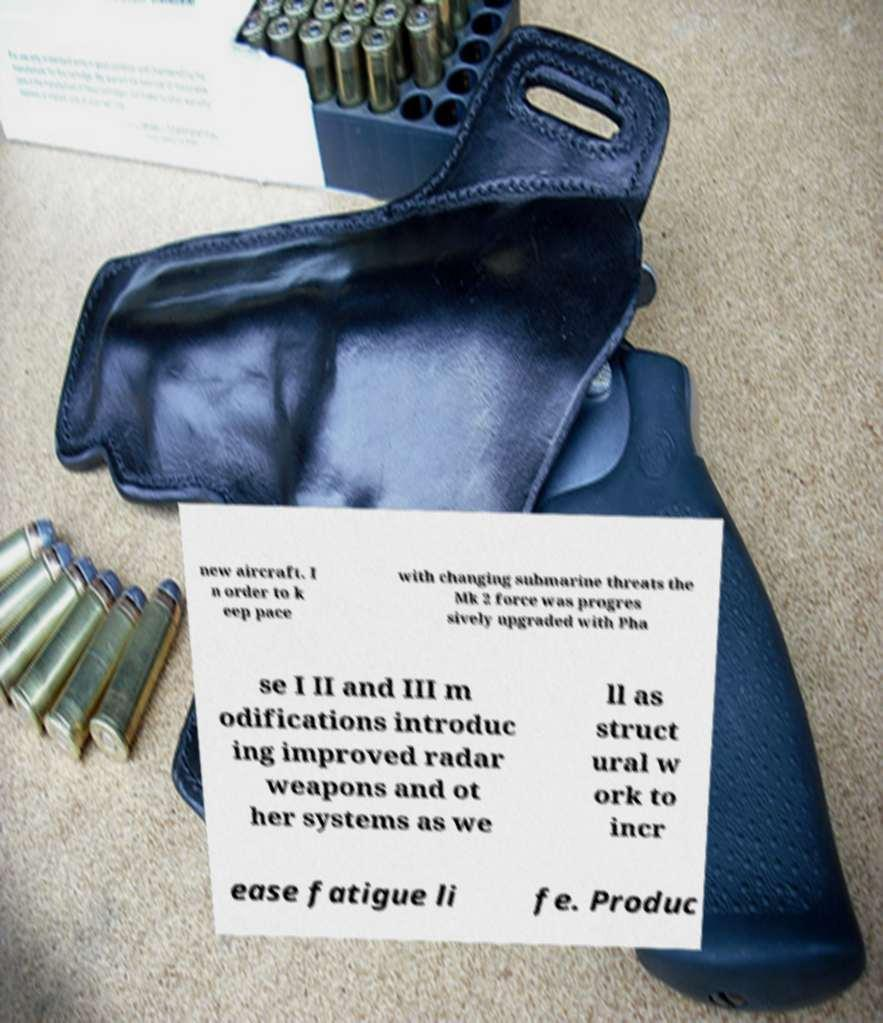For documentation purposes, I need the text within this image transcribed. Could you provide that? new aircraft. I n order to k eep pace with changing submarine threats the Mk 2 force was progres sively upgraded with Pha se I II and III m odifications introduc ing improved radar weapons and ot her systems as we ll as struct ural w ork to incr ease fatigue li fe. Produc 